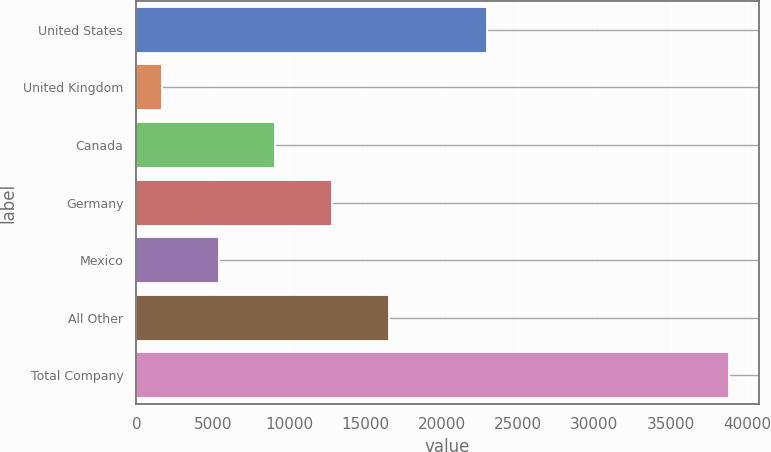<chart> <loc_0><loc_0><loc_500><loc_500><bar_chart><fcel>United States<fcel>United Kingdom<fcel>Canada<fcel>Germany<fcel>Mexico<fcel>All Other<fcel>Total Company<nl><fcel>22986<fcel>1668<fcel>9100.4<fcel>12816.6<fcel>5384.2<fcel>16532.8<fcel>38830<nl></chart> 